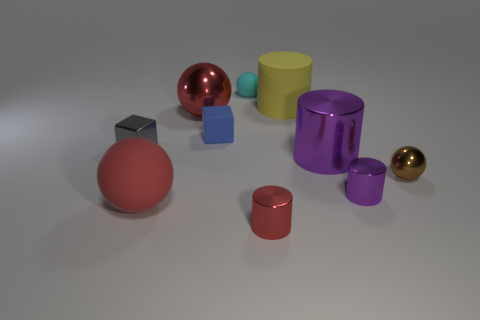Subtract all metal cylinders. How many cylinders are left? 1 Subtract all red cylinders. How many red spheres are left? 2 Subtract all brown balls. How many balls are left? 3 Subtract all red cylinders. Subtract all blue blocks. How many cylinders are left? 3 Subtract all blocks. How many objects are left? 8 Subtract all gray metallic things. Subtract all big yellow rubber objects. How many objects are left? 8 Add 3 small purple cylinders. How many small purple cylinders are left? 4 Add 7 brown cylinders. How many brown cylinders exist? 7 Subtract 0 gray balls. How many objects are left? 10 